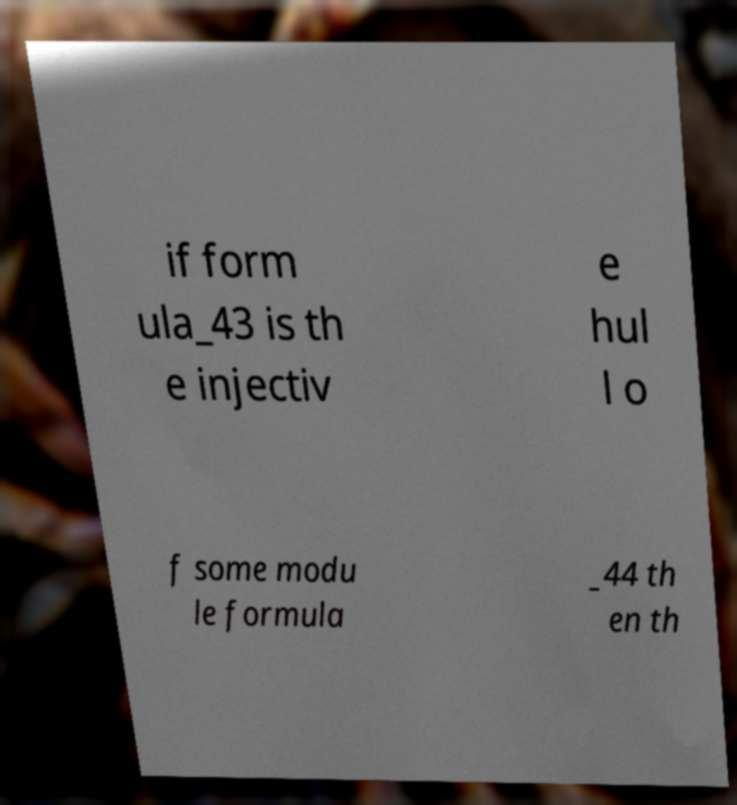Could you extract and type out the text from this image? if form ula_43 is th e injectiv e hul l o f some modu le formula _44 th en th 